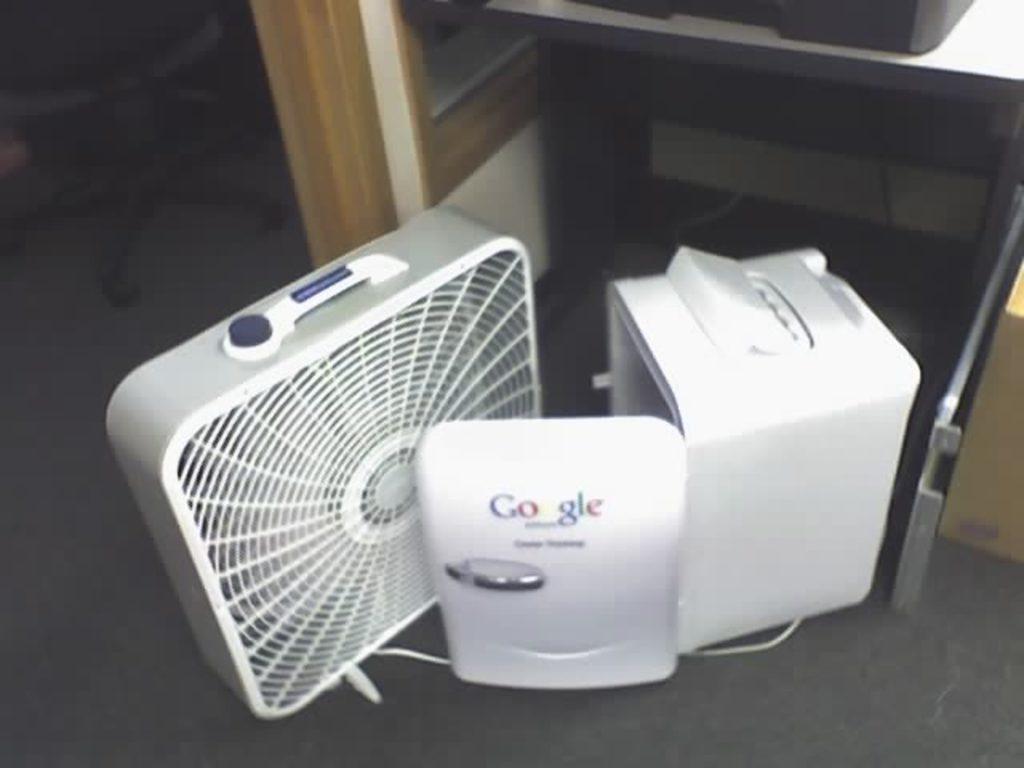Could you give a brief overview of what you see in this image? In this image, we can see some objects on the floor and in the background, there is a stand and we can see a black color on it and there is a chair. 